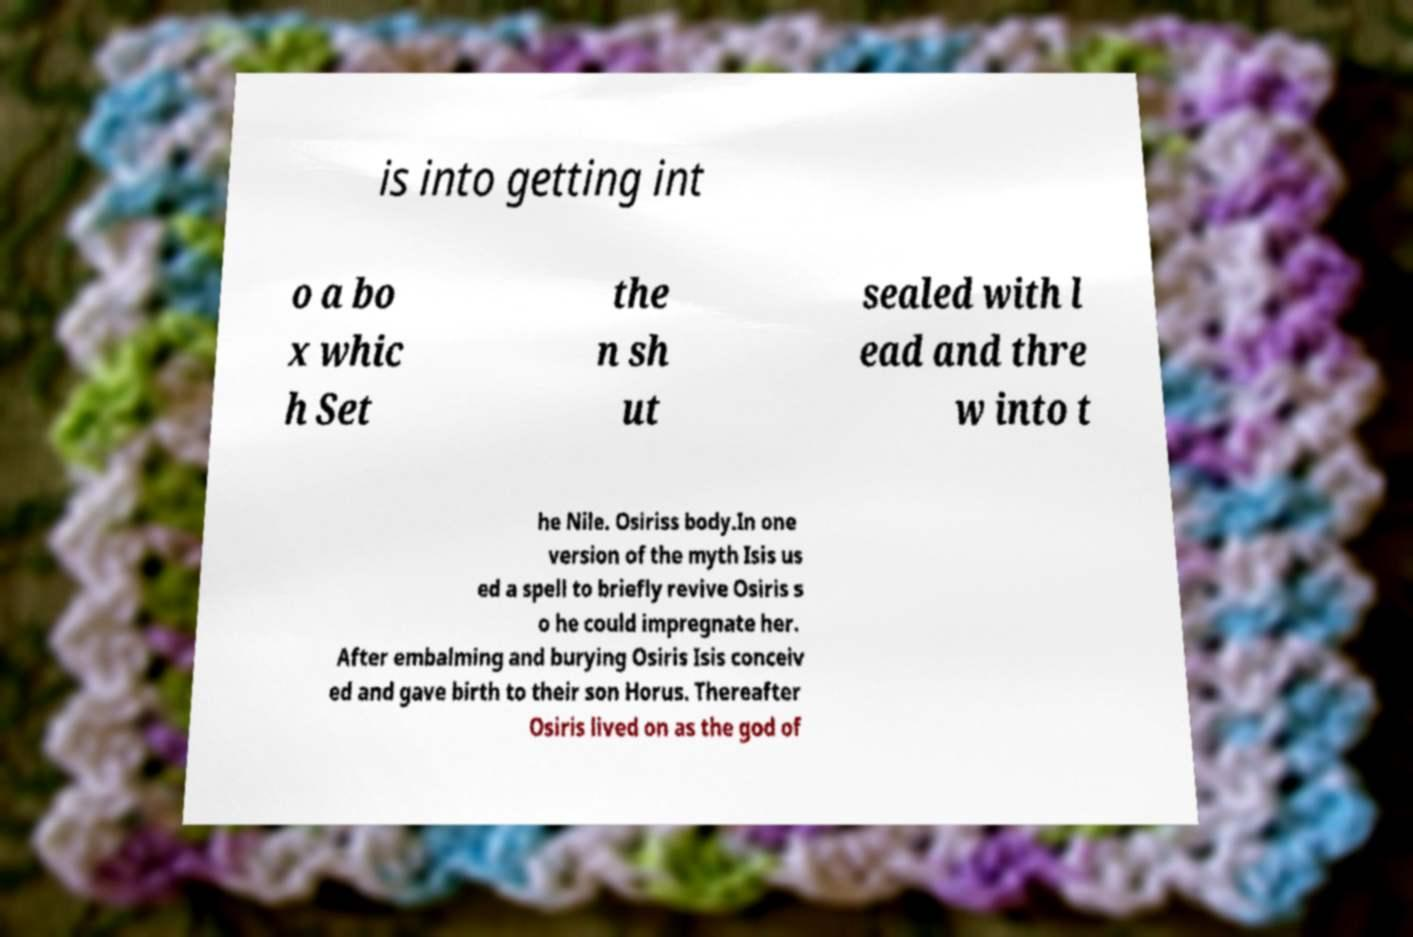Please read and relay the text visible in this image. What does it say? is into getting int o a bo x whic h Set the n sh ut sealed with l ead and thre w into t he Nile. Osiriss body.In one version of the myth Isis us ed a spell to briefly revive Osiris s o he could impregnate her. After embalming and burying Osiris Isis conceiv ed and gave birth to their son Horus. Thereafter Osiris lived on as the god of 